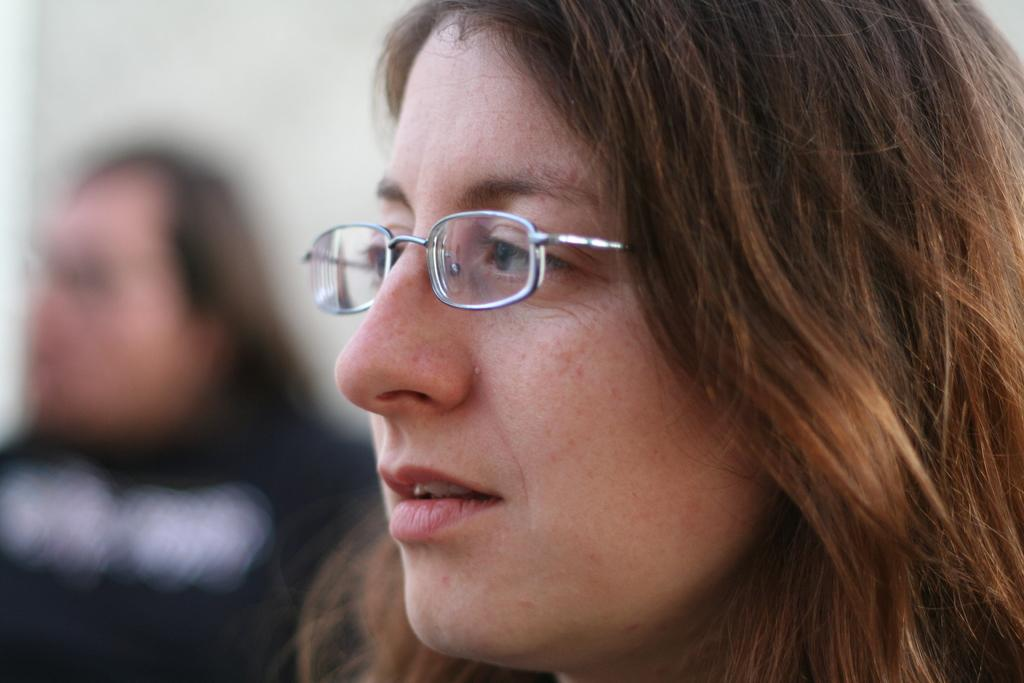Who is the main subject in the image? There is a woman in the image. What is the woman wearing in the image? The woman is wearing spectacles in the image. How is the background of the woman depicted in the image? The background of the woman is blurred in the image. What type of pancake can be seen on the border of the image? There is no pancake present in the image, and there is no border depicted in the image. 